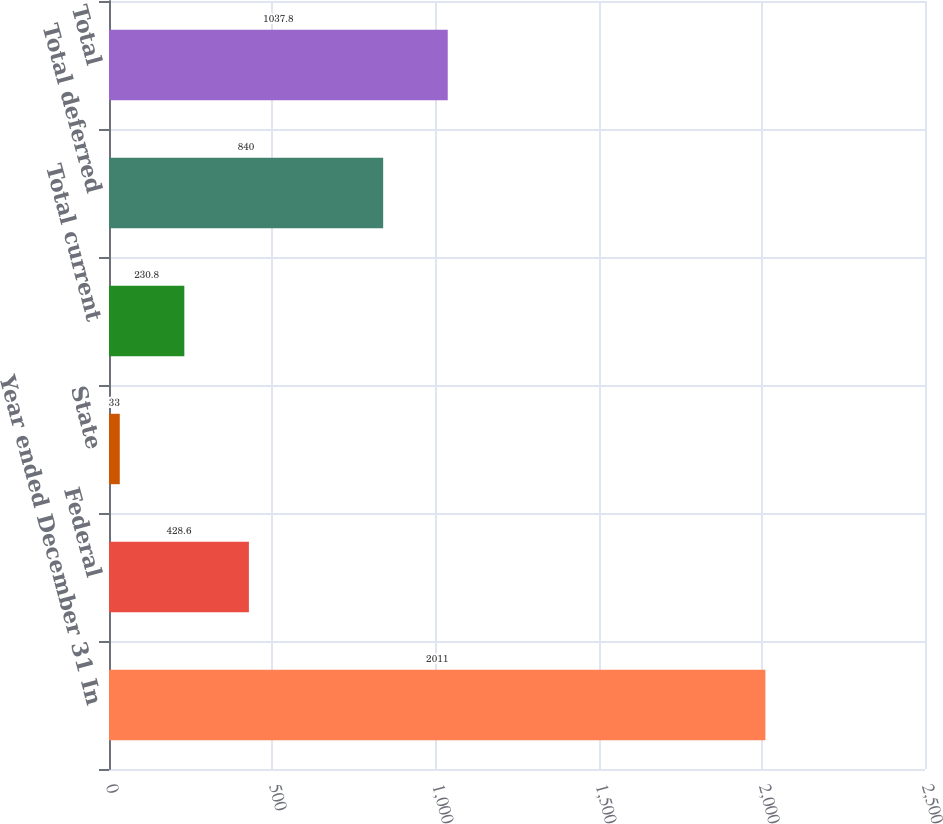Convert chart to OTSL. <chart><loc_0><loc_0><loc_500><loc_500><bar_chart><fcel>Year ended December 31 In<fcel>Federal<fcel>State<fcel>Total current<fcel>Total deferred<fcel>Total<nl><fcel>2011<fcel>428.6<fcel>33<fcel>230.8<fcel>840<fcel>1037.8<nl></chart> 